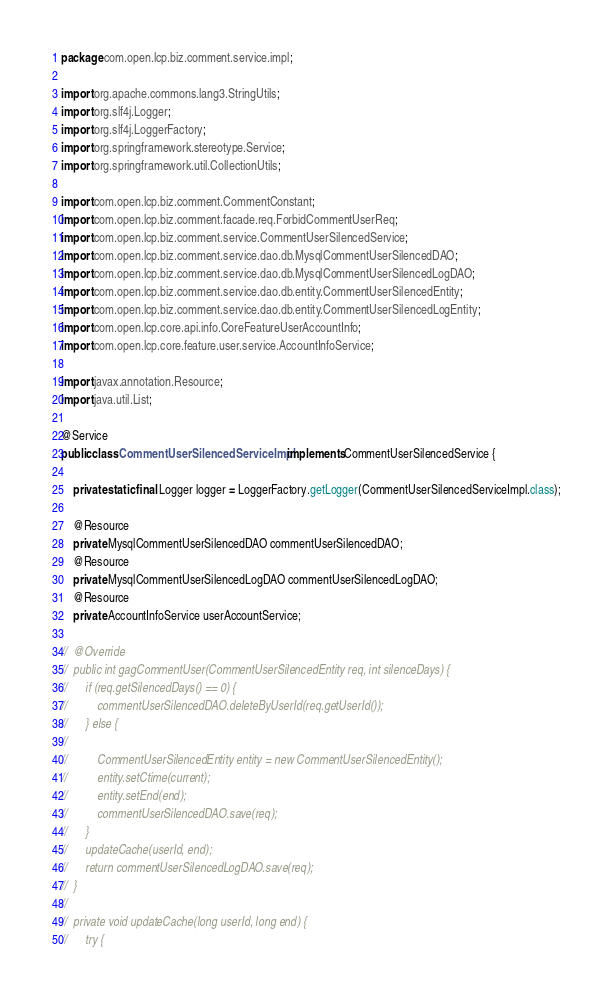<code> <loc_0><loc_0><loc_500><loc_500><_Java_>package com.open.lcp.biz.comment.service.impl;

import org.apache.commons.lang3.StringUtils;
import org.slf4j.Logger;
import org.slf4j.LoggerFactory;
import org.springframework.stereotype.Service;
import org.springframework.util.CollectionUtils;

import com.open.lcp.biz.comment.CommentConstant;
import com.open.lcp.biz.comment.facade.req.ForbidCommentUserReq;
import com.open.lcp.biz.comment.service.CommentUserSilencedService;
import com.open.lcp.biz.comment.service.dao.db.MysqlCommentUserSilencedDAO;
import com.open.lcp.biz.comment.service.dao.db.MysqlCommentUserSilencedLogDAO;
import com.open.lcp.biz.comment.service.dao.db.entity.CommentUserSilencedEntity;
import com.open.lcp.biz.comment.service.dao.db.entity.CommentUserSilencedLogEntity;
import com.open.lcp.core.api.info.CoreFeatureUserAccountInfo;
import com.open.lcp.core.feature.user.service.AccountInfoService;

import javax.annotation.Resource;
import java.util.List;

@Service
public class CommentUserSilencedServiceImpl implements CommentUserSilencedService {

	private static final Logger logger = LoggerFactory.getLogger(CommentUserSilencedServiceImpl.class);

	@Resource
	private MysqlCommentUserSilencedDAO commentUserSilencedDAO;
	@Resource
	private MysqlCommentUserSilencedLogDAO commentUserSilencedLogDAO;
	@Resource
	private AccountInfoService userAccountService;

//	@Override
//	public int gagCommentUser(CommentUserSilencedEntity req, int silenceDays) {
//		if (req.getSilencedDays() == 0) {
//			commentUserSilencedDAO.deleteByUserId(req.getUserId());
//		} else {
//
//			CommentUserSilencedEntity entity = new CommentUserSilencedEntity();
//			entity.setCtime(current);
//			entity.setEnd(end);
//			commentUserSilencedDAO.save(req);
//		}
//		updateCache(userId, end);
//		return commentUserSilencedLogDAO.save(req);
//	}
//
//	private void updateCache(long userId, long end) {
//		try {</code> 